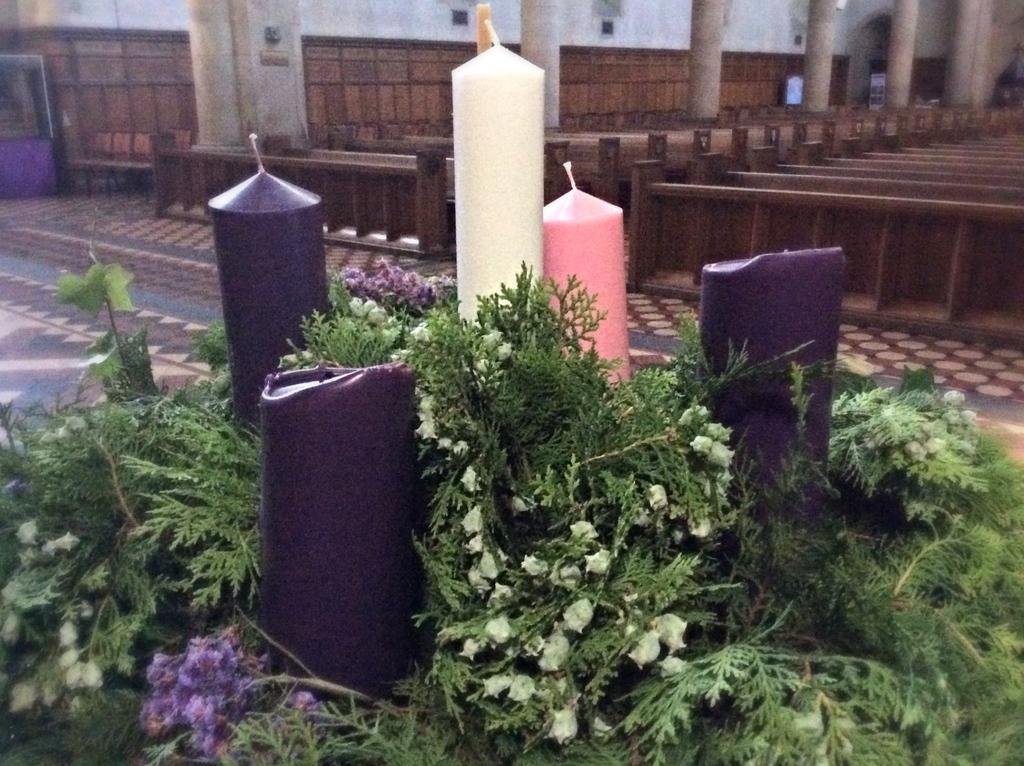Could you give a brief overview of what you see in this image? In this picture there is a inside view of the church. In the front there are big candles and some green plants. Behind we can see some wooden benches. 